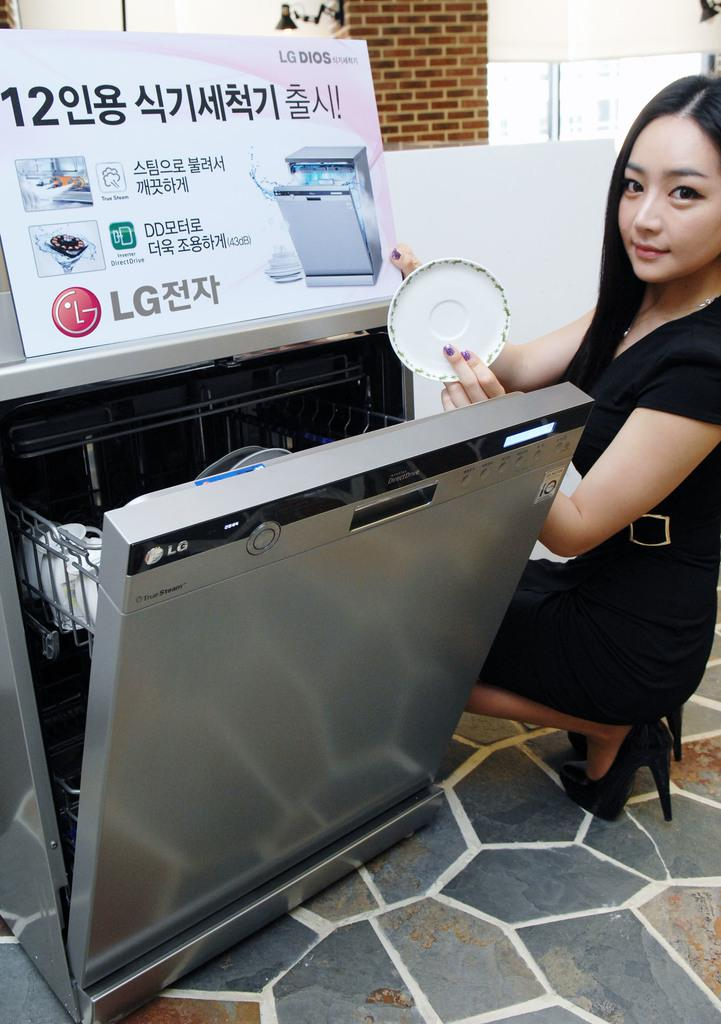<image>
Summarize the visual content of the image. a women showing a clean dish out of an LG dishwasher. 